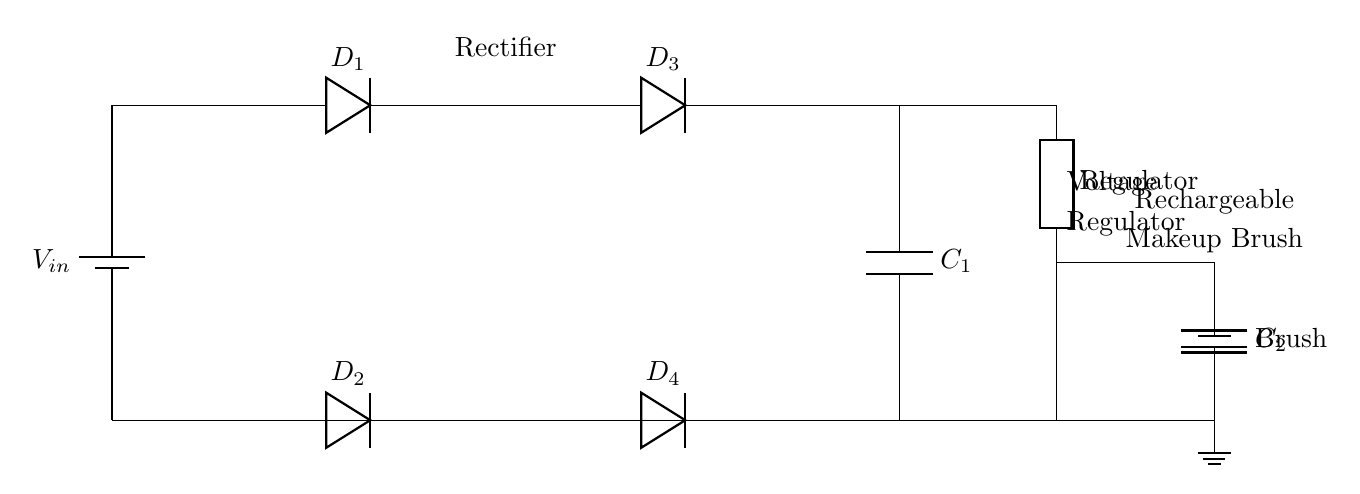What is the function of the diodes in this circuit? The diodes serve the function of rectifying the AC voltage from the battery into DC voltage, allowing current to flow in a single direction, which is necessary for the operation of the makeup brush.
Answer: Rectification What type of capacitor is C1? C1 is a smoothing capacitor that evens out the fluctuations in the output voltage after the rectification process, providing a stable DC voltage to the voltage regulator.
Answer: Smoothing How many diodes are used in this power supply circuit? There are four diodes used in this circuit, arranged in a full-wave bridge rectifier configuration to ensure efficient rectification of the AC voltage.
Answer: Four What component regulates the voltage for the brush? The component that regulates the voltage for the brush is the voltage regulator, which is responsible for maintaining a steady output voltage despite variations in the input voltage or load conditions.
Answer: Voltage regulator What is the purpose of C2 in the circuit? C2 serves as an output capacitor that filters and stabilizes the voltage supplied to the rechargeable electric makeup brush, smoothing out any residual fluctuations.
Answer: Filtering 